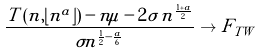<formula> <loc_0><loc_0><loc_500><loc_500>\frac { T \left ( n , \lfloor n ^ { a } \rfloor \right ) - n \mu - 2 \sigma \, n ^ { \frac { 1 + a } { 2 } } } { \sigma n ^ { \frac { 1 } { 2 } - \frac { a } { 6 } } } \to F _ { T W }</formula> 